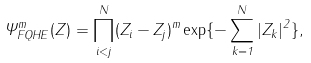Convert formula to latex. <formula><loc_0><loc_0><loc_500><loc_500>\Psi ^ { m } _ { F Q H E } ( Z ) = \prod ^ { N } _ { i < j } ( Z _ { i } - Z _ { j } ) ^ { m } \exp \{ - \sum ^ { N } _ { k = 1 } | Z _ { k } | ^ { 2 } \} ,</formula> 